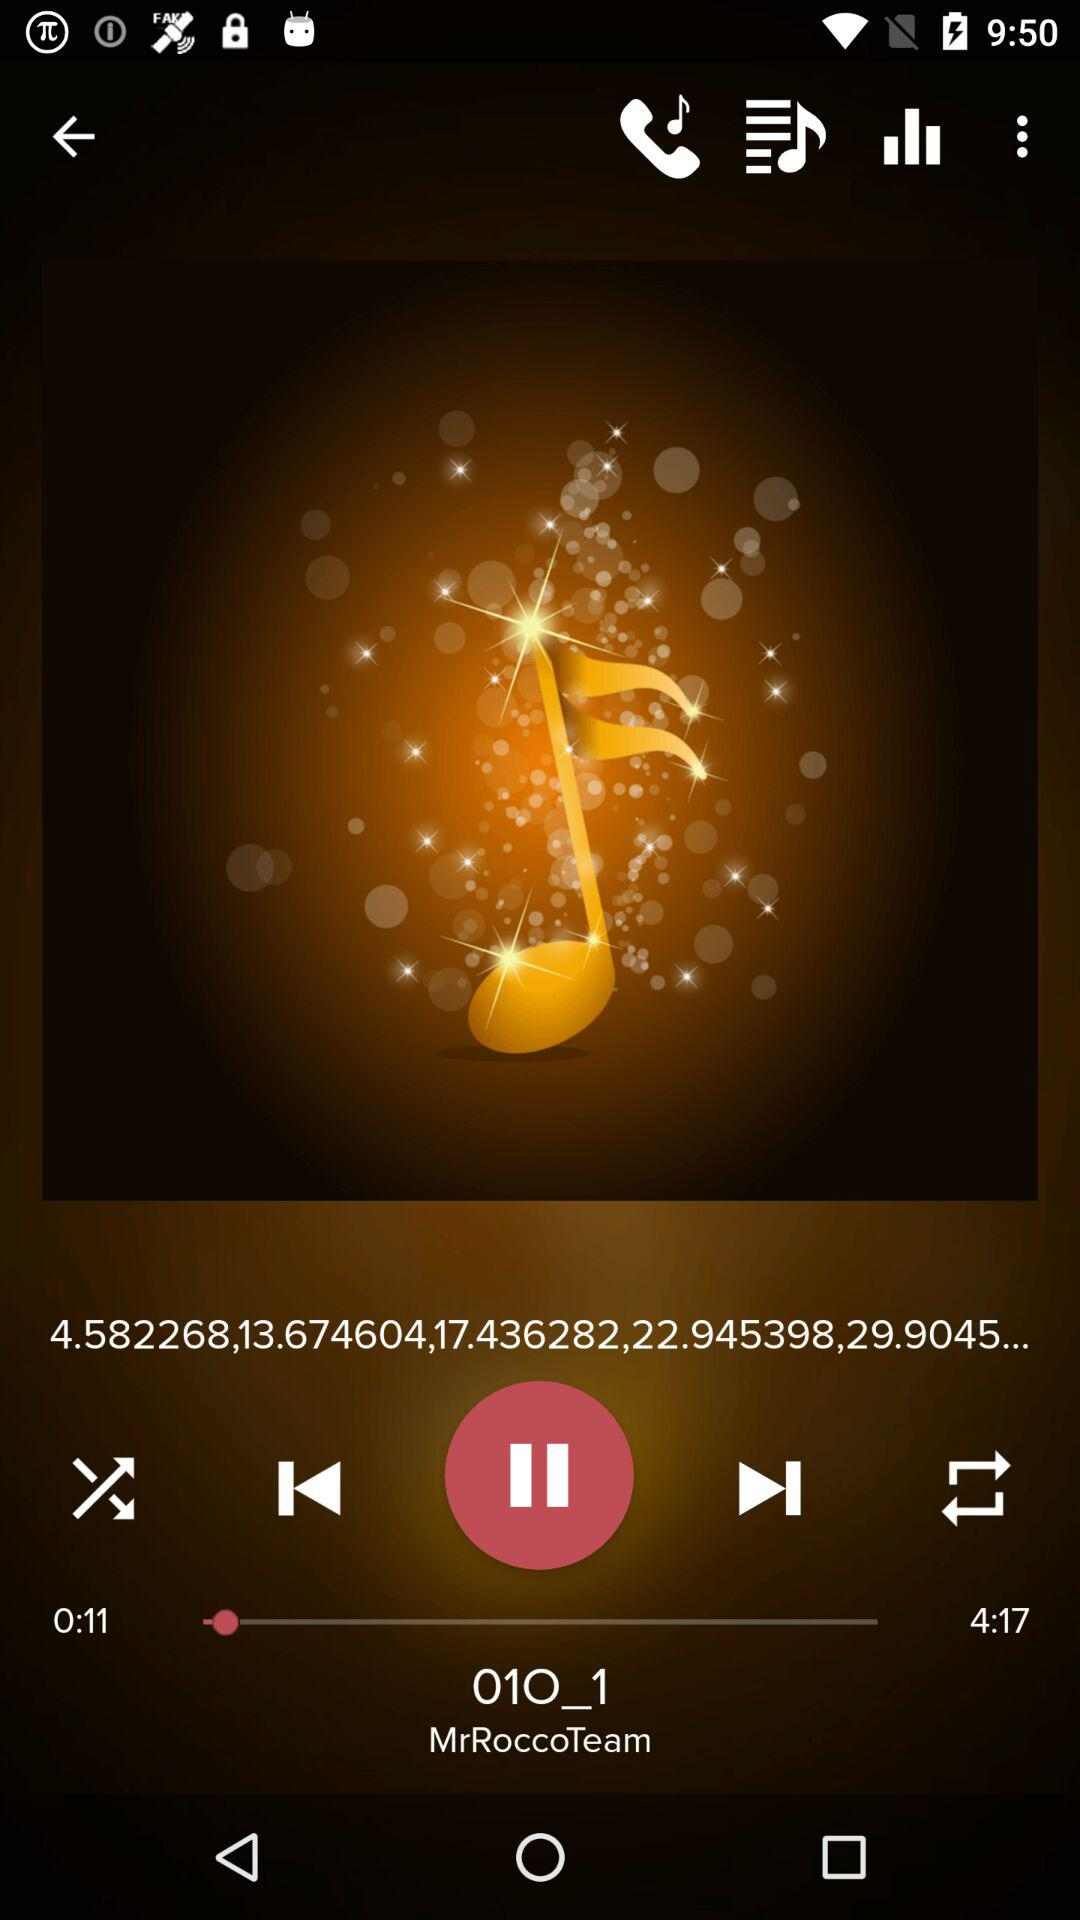Which audio is playing? The audio that is playing is "01O_1". 